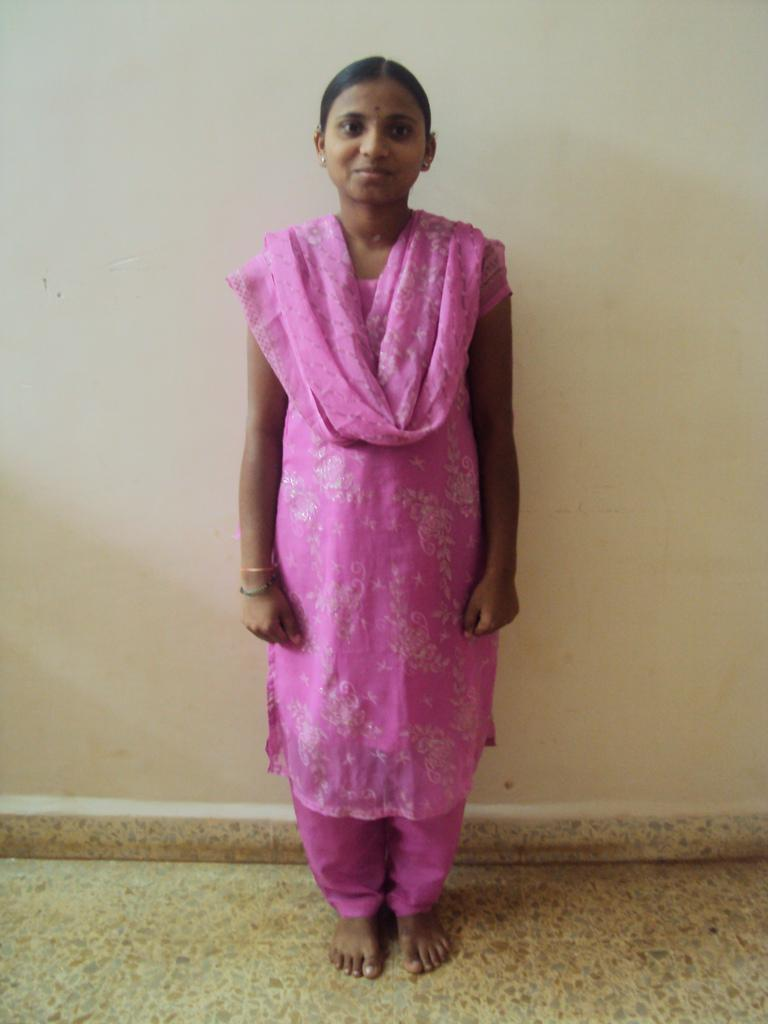Who is present in the image? There is a woman in the image. What is the woman wearing? The woman is wearing a pink dress. What is the woman's facial expression? The woman is smiling. What surface is the woman standing on? The woman is standing on the floor. What can be seen in the background of the image? There is a white wall in the background of the image. What type of chin is visible on the fireman in the image? There is no fireman present in the image, and therefore no chin to observe. 